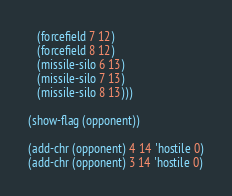<code> <loc_0><loc_0><loc_500><loc_500><_Lisp_>   (forcefield 7 12)
   (forcefield 8 12)
   (missile-silo 6 13)
   (missile-silo 7 13)
   (missile-silo 8 13)))

(show-flag (opponent))

(add-chr (opponent) 4 14 'hostile 0)
(add-chr (opponent) 3 14 'hostile 0)
</code> 